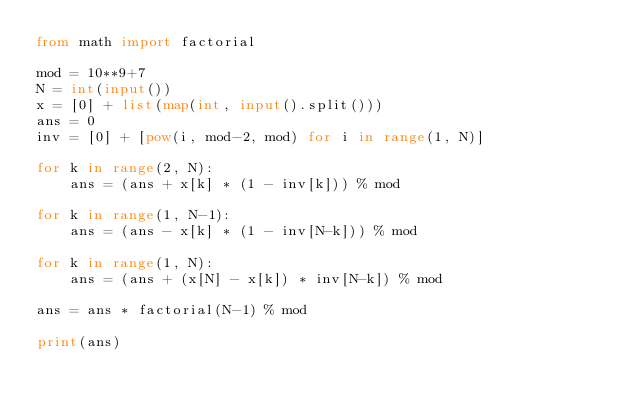<code> <loc_0><loc_0><loc_500><loc_500><_Python_>from math import factorial

mod = 10**9+7
N = int(input())
x = [0] + list(map(int, input().split()))
ans = 0
inv = [0] + [pow(i, mod-2, mod) for i in range(1, N)]

for k in range(2, N):
    ans = (ans + x[k] * (1 - inv[k])) % mod

for k in range(1, N-1):
    ans = (ans - x[k] * (1 - inv[N-k])) % mod

for k in range(1, N):
    ans = (ans + (x[N] - x[k]) * inv[N-k]) % mod

ans = ans * factorial(N-1) % mod

print(ans)
</code> 